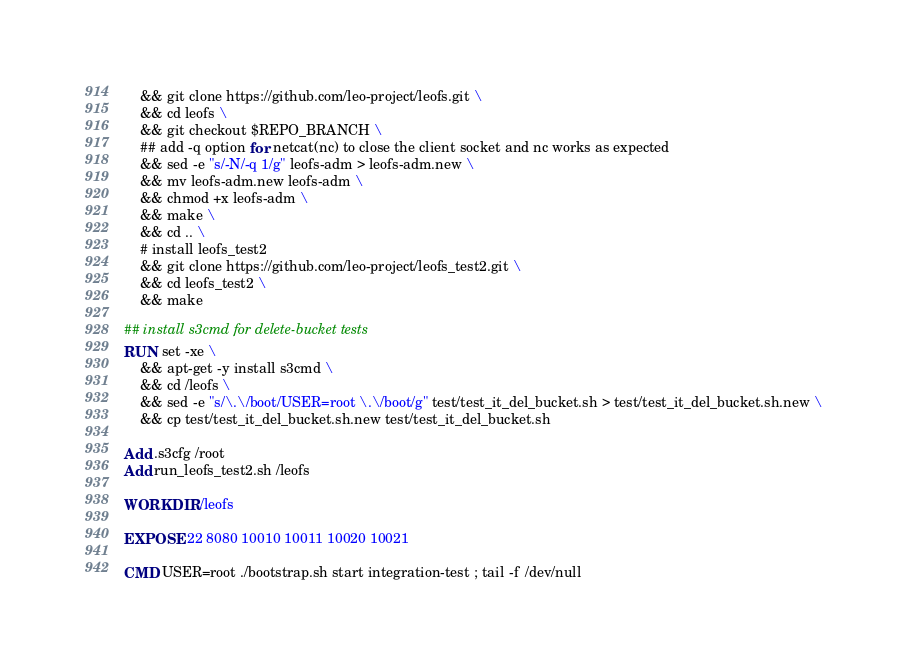Convert code to text. <code><loc_0><loc_0><loc_500><loc_500><_Dockerfile_>    && git clone https://github.com/leo-project/leofs.git \
    && cd leofs \
    && git checkout $REPO_BRANCH \
    ## add -q option for netcat(nc) to close the client socket and nc works as expected
    && sed -e "s/-N/-q 1/g" leofs-adm > leofs-adm.new \
    && mv leofs-adm.new leofs-adm \
    && chmod +x leofs-adm \
    && make \
    && cd .. \ 
    # install leofs_test2
    && git clone https://github.com/leo-project/leofs_test2.git \
    && cd leofs_test2 \
    && make

## install s3cmd for delete-bucket tests
RUN set -xe \
    && apt-get -y install s3cmd \
    && cd /leofs \
    && sed -e "s/\.\/boot/USER=root \.\/boot/g" test/test_it_del_bucket.sh > test/test_it_del_bucket.sh.new \
    && cp test/test_it_del_bucket.sh.new test/test_it_del_bucket.sh

Add .s3cfg /root
Add run_leofs_test2.sh /leofs

WORKDIR /leofs

EXPOSE 22 8080 10010 10011 10020 10021

CMD USER=root ./bootstrap.sh start integration-test ; tail -f /dev/null
</code> 